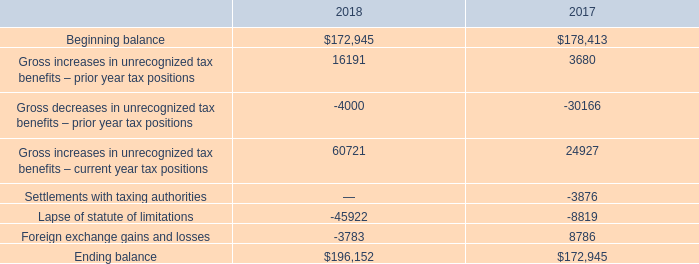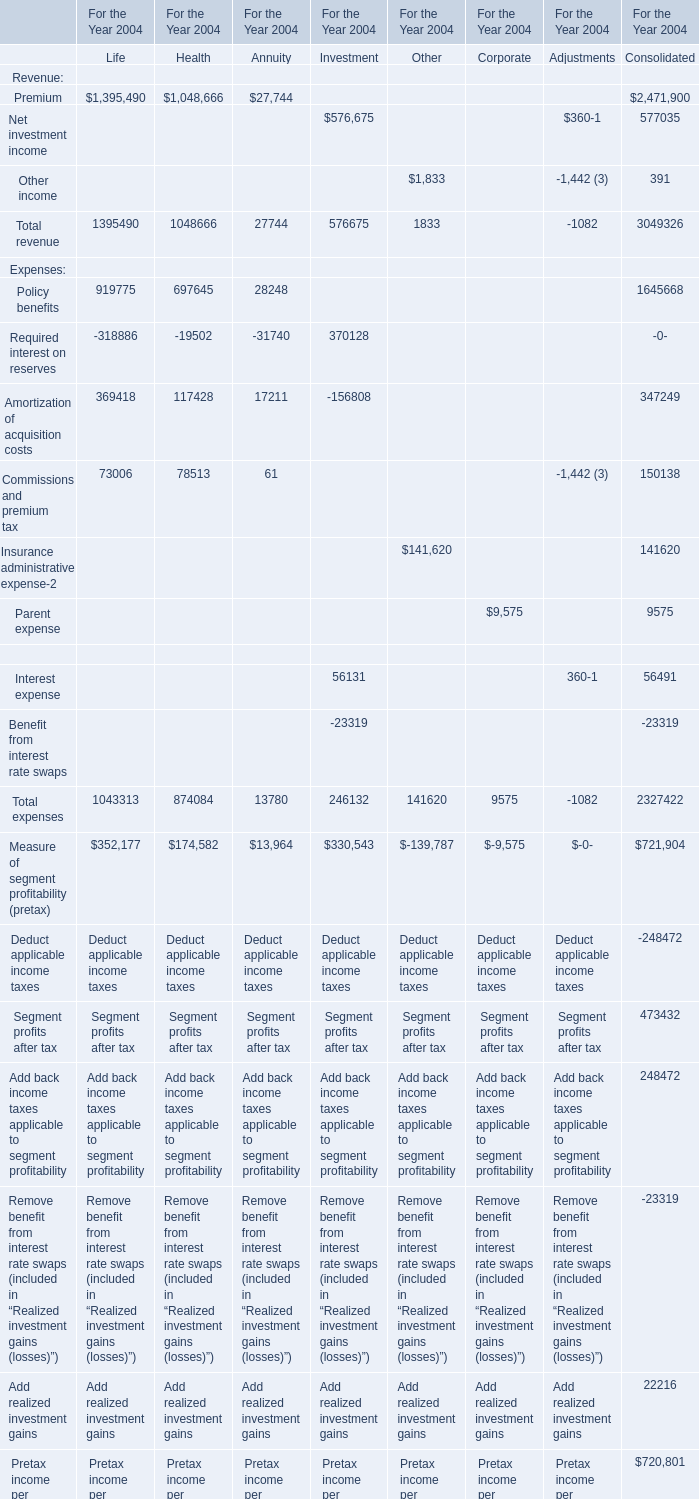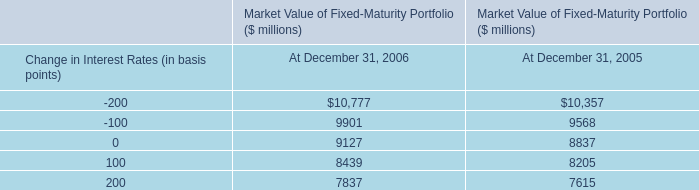what's the total amount of Net investment income of For the Year 2004 Consolidated, and Ending balance of 2017 ? 
Computations: (577035.0 + 172945.0)
Answer: 749980.0. 